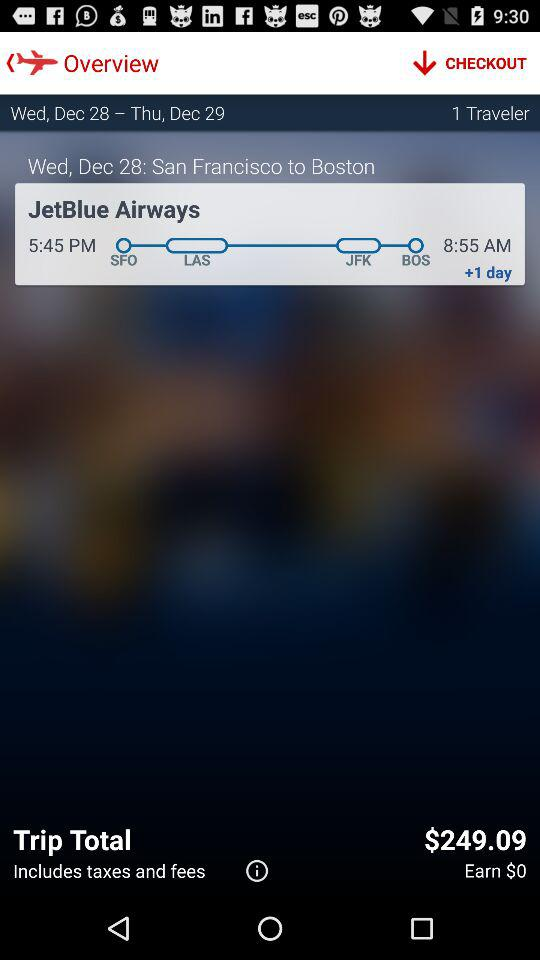Where does the journey start and end? The journey starts from San Francisco and ends in Boston. 